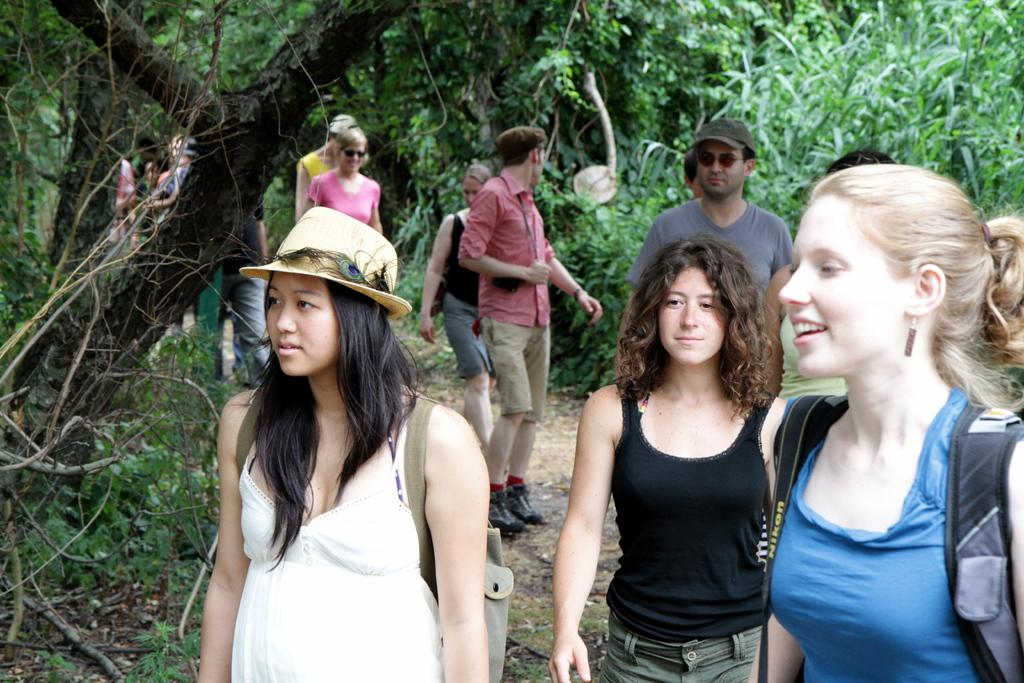What types of people are present in the image? There are men and women in the image. What are the men and women doing in the image? The men and women are walking in the image. What can be seen in the background of the image? There are trees in the image. What type of range can be seen in the image? There is no range present in the image; it features men and women walking with trees in the background. 